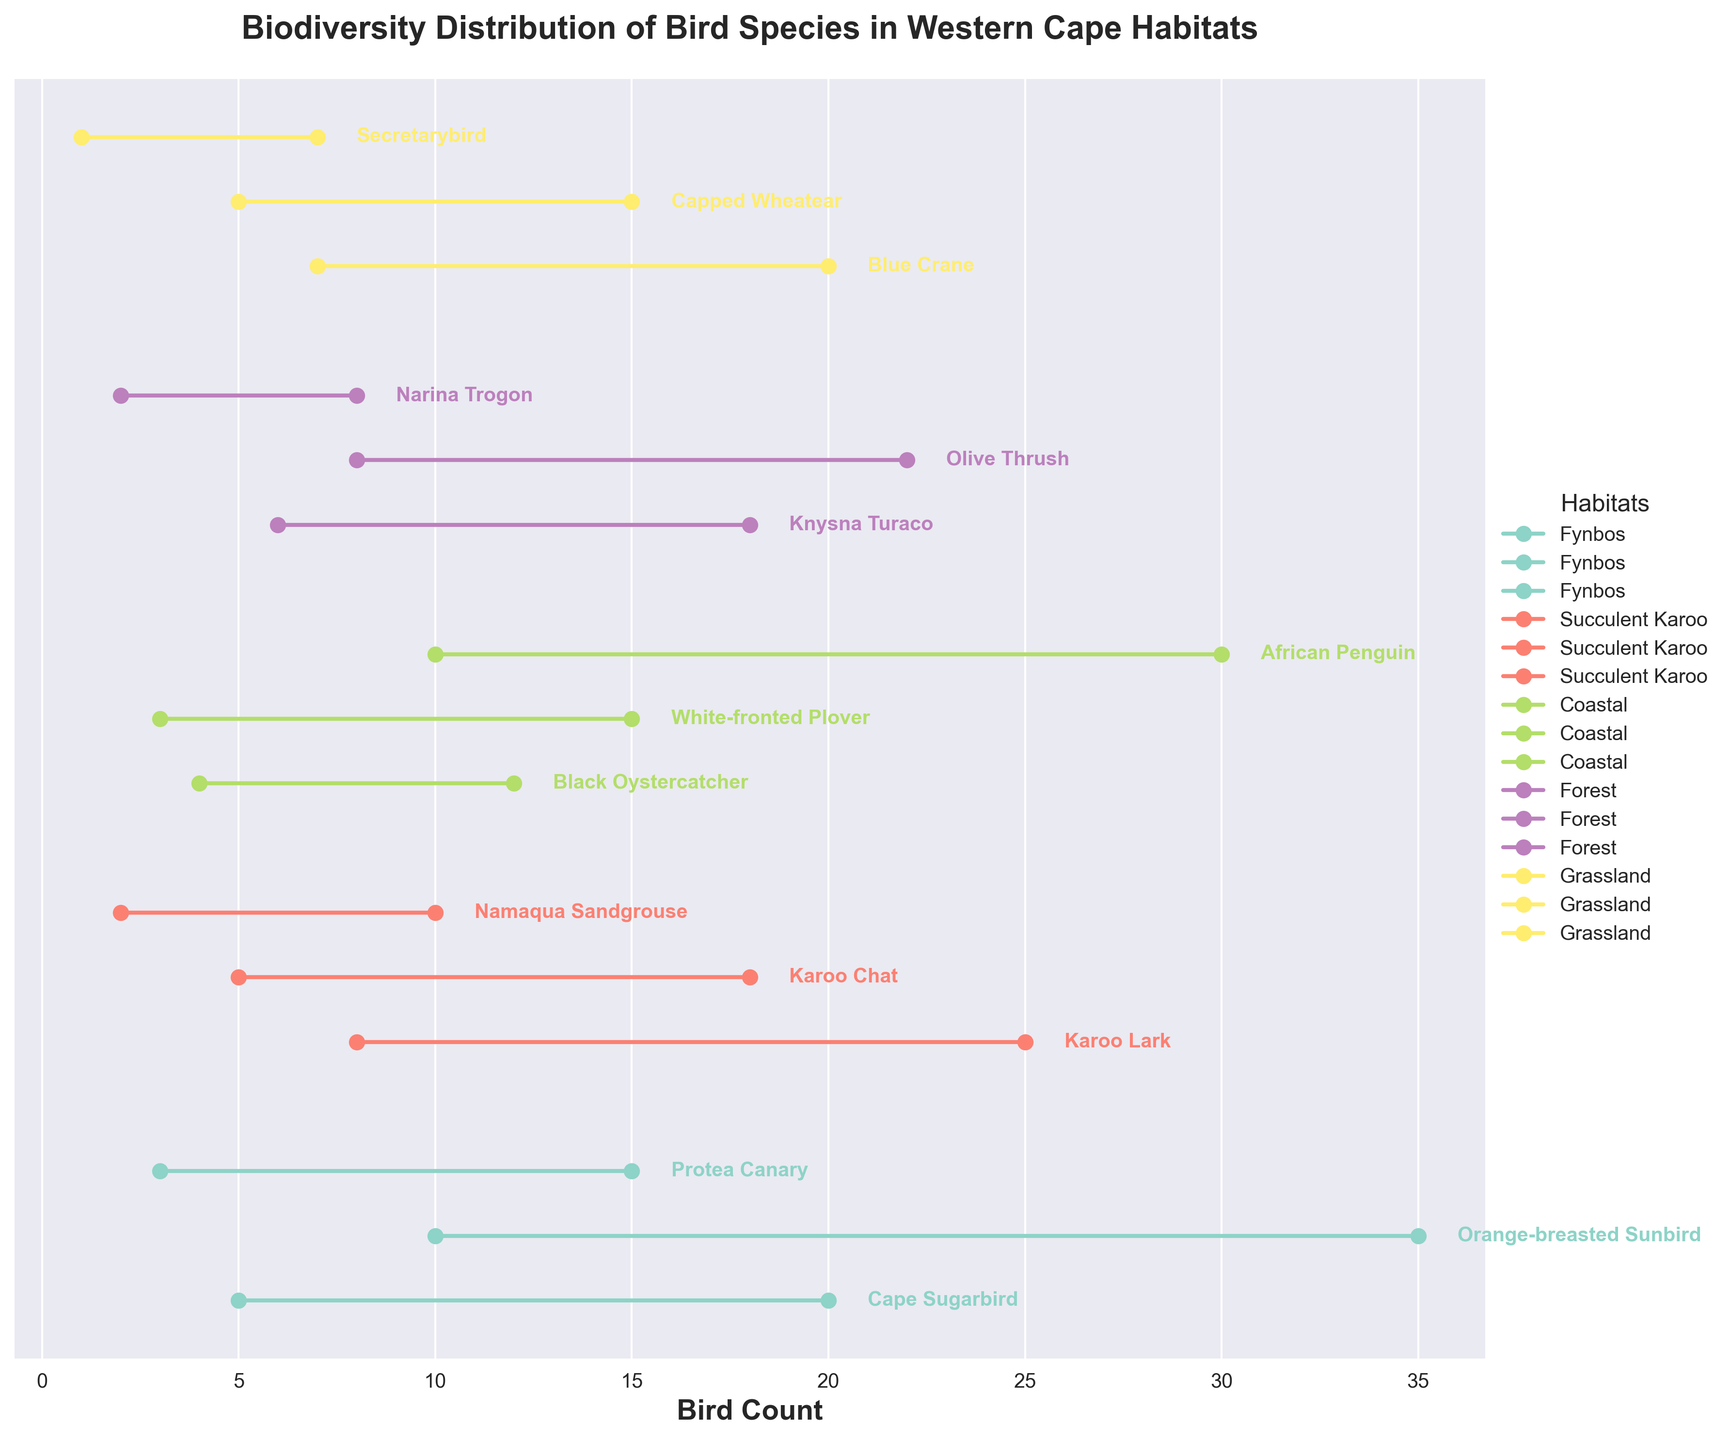What is the maximum count of Orange-breasted Sunbird in Fynbos? Locate the Orange-breasted Sunbird in the Fynbos habitat section, then read the maximum count value on the figure.
Answer: 35 Which habitat has the species with the smallest minimum count? Compare the minimum counts for all species in each habitat. The smallest minimum count is found in the habitat with the Secretarybird, the Grassland.
Answer: Grassland How many bird species are represented in the Coastal habitat? Count the number of species names in the Coastal habitat section.
Answer: 3 What's the range of counts for the Narina Trogon in the Forest habitat? Locate the Narina Trogon in the Forest habitat section and calculate the difference between its maximum and minimum counts (Max - Min).
Answer: 6 Which bird species has the highest maximum count in the Grassland habitat? Check all maximum counts in the Grassland habitat and identify the species with the highest one.
Answer: Blue Crane Which bird species in the Forest habitat has a minimum count of 2? Locate the species in the Forest habitat with a minimum count of 2.
Answer: Narina Trogon What is the average maximum count for bird species in the Succulent Karoo habitat? The maximum counts for species in the Succulent Karoo are 25, 18, and 10. Calculate the sum of these values and divide by the number of species, which is 3. (25 + 18 + 10) / 3
Answer: 17.67 Compare the range of counts for the Cape Sugarbird in Fynbos and the Blue Crane in Grassland. Which one has a larger range? Calculate the range as Max - Min for both species. Cape Sugarbird range: 20 - 5 = 15. Blue Crane range: 20 - 7 = 13. Compare the two ranges.
Answer: Cape Sugarbird In which habitat can you find the species with the highest maximum count overall? Identify the species with the highest maximum count by comparing all the maximum counts and locate its habitat.
Answer: Fynbos How many species have a maximum count that exceeds 20 in total? Look at all species across all habitats and count those whose maximum counts are greater than 20.
Answer: 4 